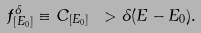Convert formula to latex. <formula><loc_0><loc_0><loc_500><loc_500>f ^ { \delta } _ { [ E _ { 0 } ] } \equiv C _ { [ E _ { 0 } ] } \ > \delta ( E - E _ { 0 } ) .</formula> 